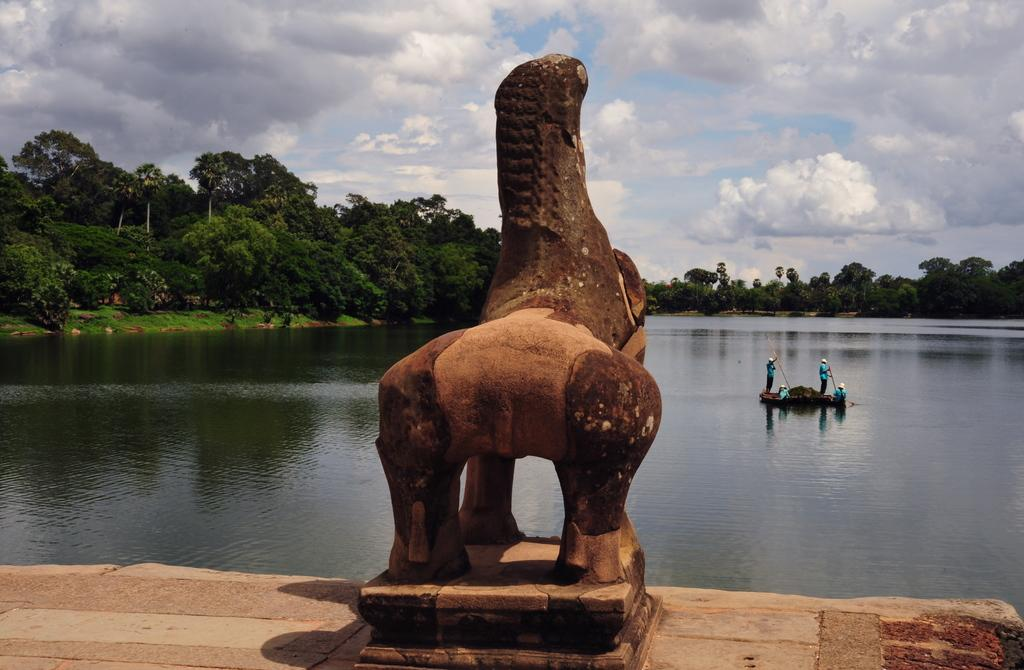What is the main subject of the image? There is a sculptor in the image. What else can be seen in the image besides the sculptor? There are people in a boat and trees in the image. Are there any plants visible in the image? Yes, there are plants in the image. How many dogs are sitting on the van in the image? There is no van or dogs present in the image. 